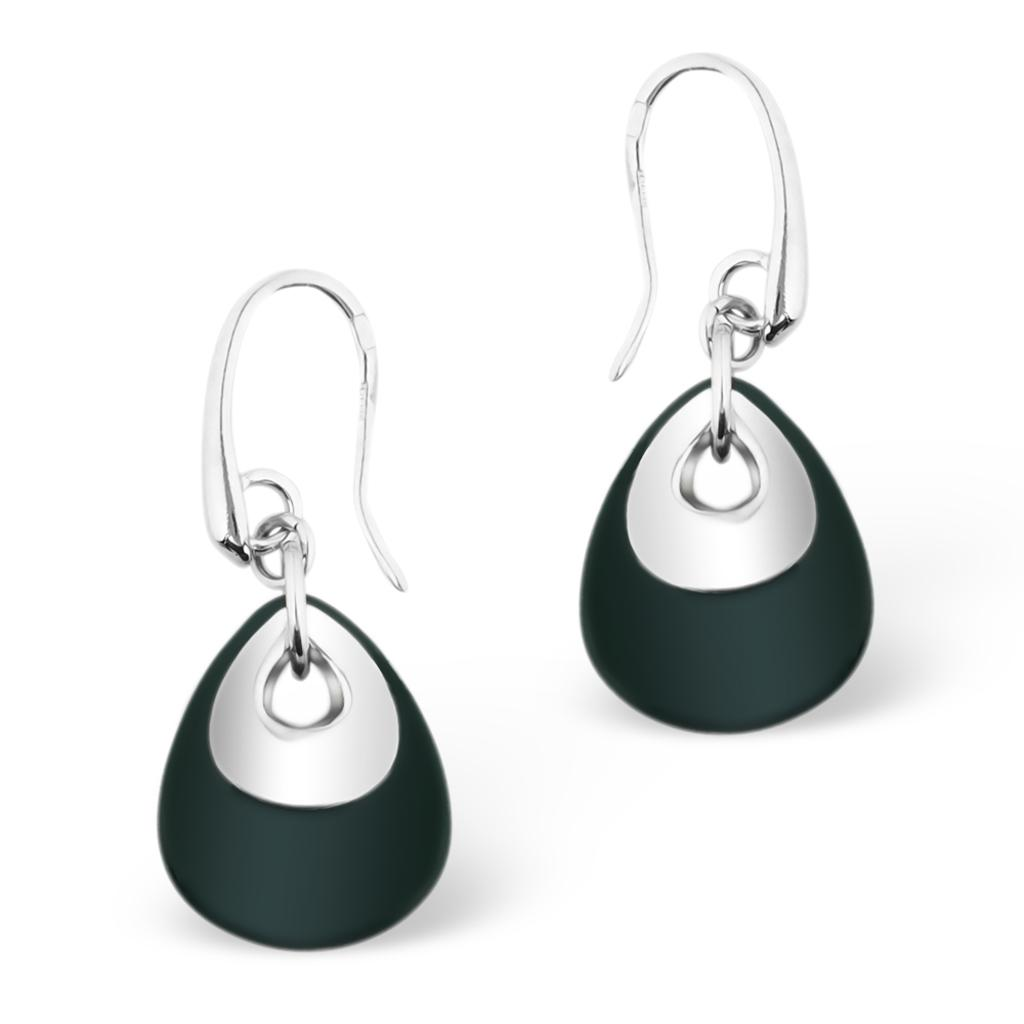What type of accessory is featured in the image? There are two earrings in the image. What color are the earrings? Both earrings are black in color. How many fingers does the visitor have in the image? There is no visitor present in the image, so it is not possible to determine the number of fingers they might have. 